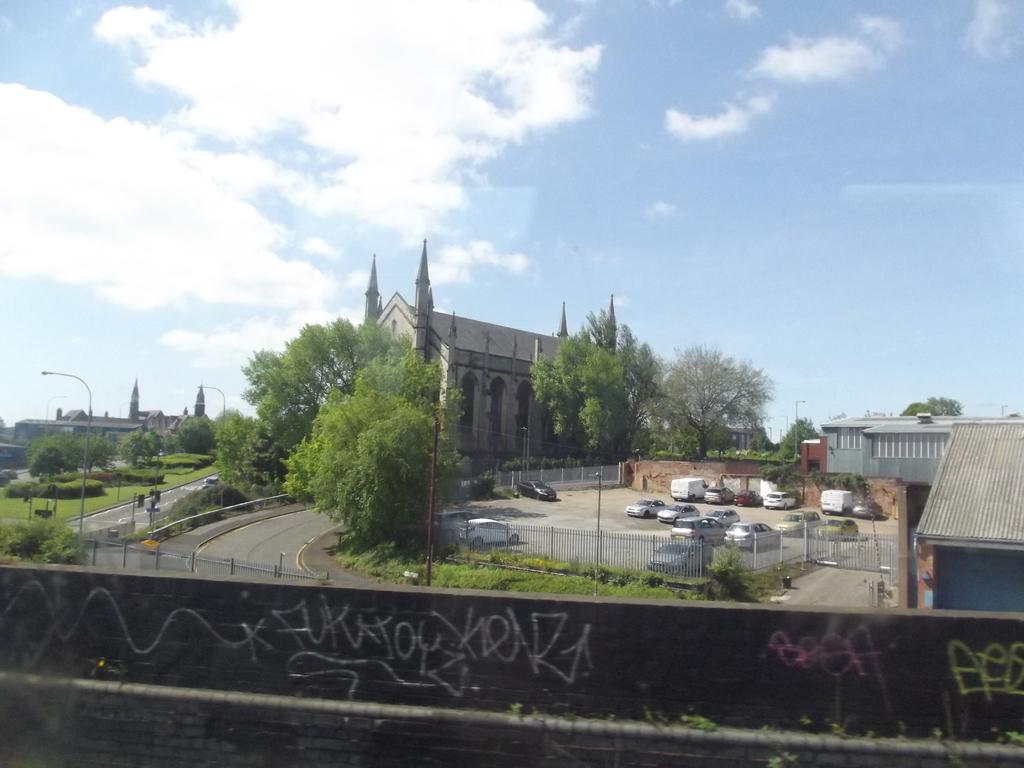<image>
Give a short and clear explanation of the subsequent image. The word beef is written in pink spray paint on a stone wall. 